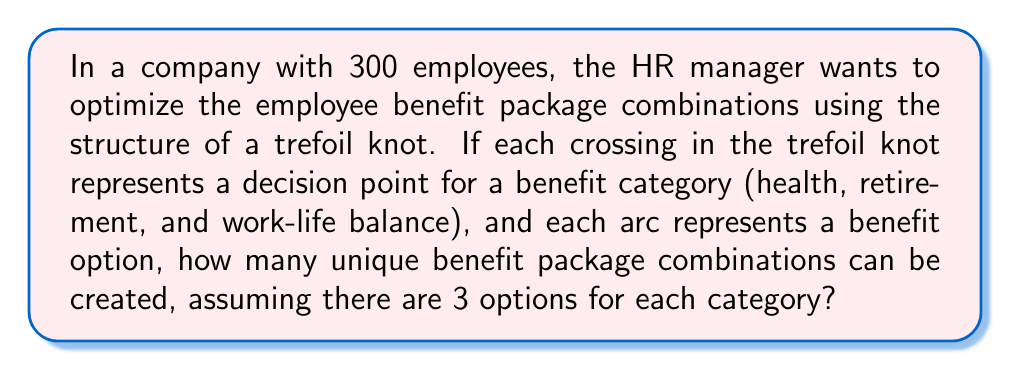Show me your answer to this math problem. Let's approach this step-by-step:

1) First, recall that a trefoil knot has 3 crossings and 3 arcs.

2) In this analogy:
   - Each crossing represents a benefit category (health, retirement, work-life balance)
   - Each arc represents a benefit option

3) We are told there are 3 options for each category.

4) To calculate the total number of unique combinations, we use the multiplication principle:

   $$ \text{Total combinations} = \text{Options for Health} \times \text{Options for Retirement} \times \text{Options for Work-Life Balance} $$

5) Substituting the values:

   $$ \text{Total combinations} = 3 \times 3 \times 3 = 3^3 = 27 $$

6) Therefore, there are 27 unique benefit package combinations that can be created.

This structure allows for a systematic approach to benefit package design, where each "traversal" of the trefoil knot represents a unique combination of benefits across all three categories.
Answer: 27 combinations 